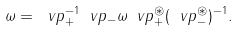Convert formula to latex. <formula><loc_0><loc_0><loc_500><loc_500>\omega = \ v p _ { + } ^ { - 1 } \ v p _ { - } \omega \ v p _ { + } ^ { \circledast } ( \ v p _ { - } ^ { \circledast } ) ^ { - 1 } .</formula> 